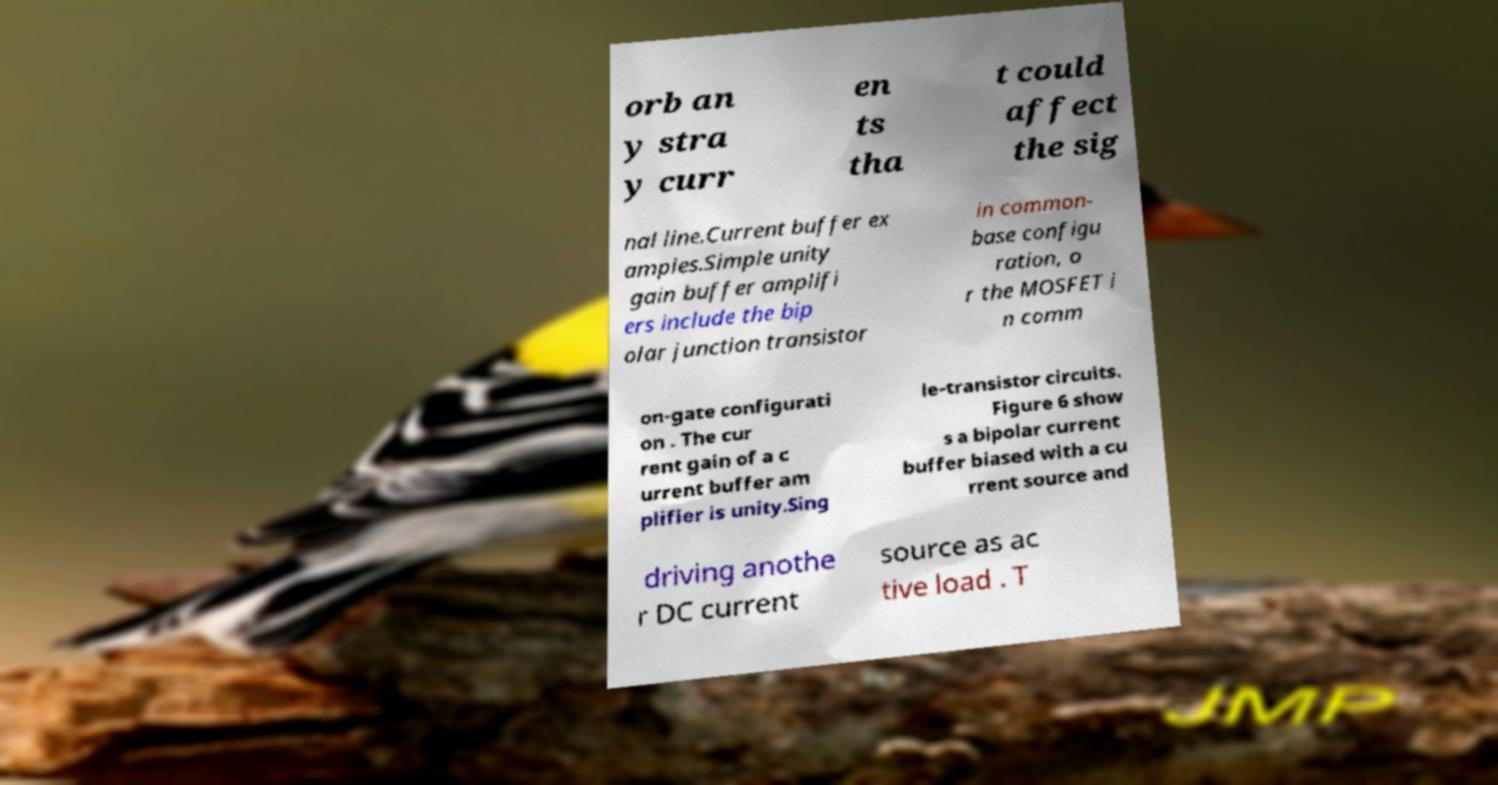Please read and relay the text visible in this image. What does it say? orb an y stra y curr en ts tha t could affect the sig nal line.Current buffer ex amples.Simple unity gain buffer amplifi ers include the bip olar junction transistor in common- base configu ration, o r the MOSFET i n comm on-gate configurati on . The cur rent gain of a c urrent buffer am plifier is unity.Sing le-transistor circuits. Figure 6 show s a bipolar current buffer biased with a cu rrent source and driving anothe r DC current source as ac tive load . T 